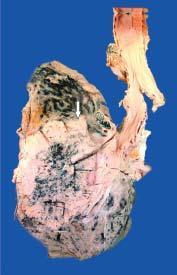s congo red seen extending directly into adjacent lung parenchyma and hilar nodes?
Answer the question using a single word or phrase. No 